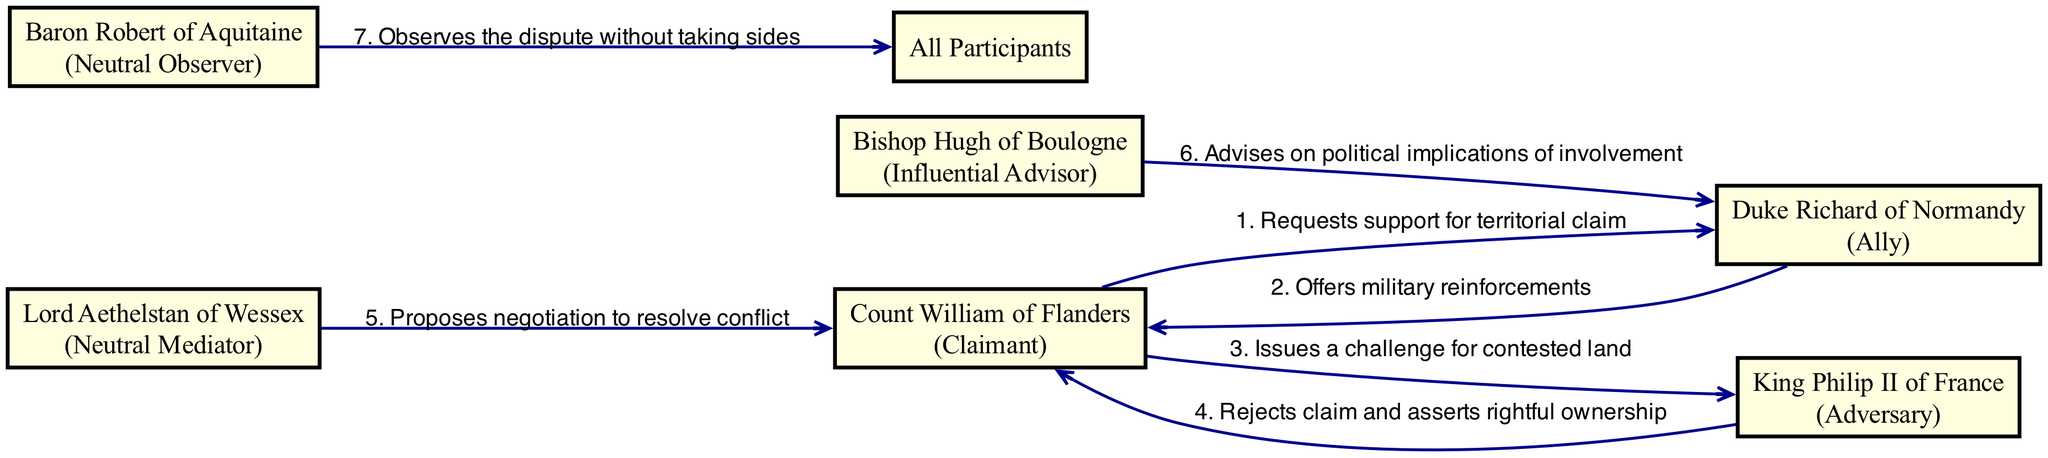What is the role of Count William of Flanders? According to the diagram, Count William of Flanders is labeled as "Claimant," indicating his role in the dispute as someone who is claiming a right to a territory.
Answer: Claimant Who offers military reinforcements? The diagram shows an interaction where Duke Richard of Normandy sends support to Count William, thus he is the one who offers military reinforcements.
Answer: Duke Richard of Normandy How many neutral parties are there? By examining the participants, we can identify Lord Aethelstan of Wessex and Baron Robert of Aquitaine as neutral entities, bringing the total count of neutral parties to two.
Answer: Two What action does King Philip II of France take in response to Count William's challenge? The diagram indicates that King Philip II of France rejects Count William's claim and asserts rightful ownership of the contested land. This action directly responds to Count William's challenge.
Answer: Rejects claim and asserts rightful ownership Which participant observes the dispute without taking sides? Baron Robert of Aquitaine is explicitly indicated in the diagram as the observer who does not take sides, fulfilling the role of a neutral observer in the dispute.
Answer: Baron Robert of Aquitaine What is the primary type of interaction between Count William and Duke Richard? The core interaction depicted is Count William requesting support from Duke Richard. This request establishes a collaborative rather than confrontational relationship in their interaction.
Answer: Requests support for territorial claim Which player proposes negotiation to resolve the conflict? The diagram shows that Lord Aethelstan of Wessex proposes negotiation, positioning him as a mediator in the dispute. His intervention suggests a desire to find a resolution beyond conflict.
Answer: Proposes negotiation to resolve conflict What advice does Bishop Hugh give to Duke Richard? According to the diagram, Bishop Hugh advises Duke Richard on the political implications of his involvement, highlighting the strategic considerations involved in supporting Count William.
Answer: Advises on political implications of involvement How many total interactions are illustrated in the diagram? By counting the interactions listed in the data, we ascertain that there are a total of seven interactions depicted in the diagram, showing the relationships and communications among players comprehensively.
Answer: Seven 